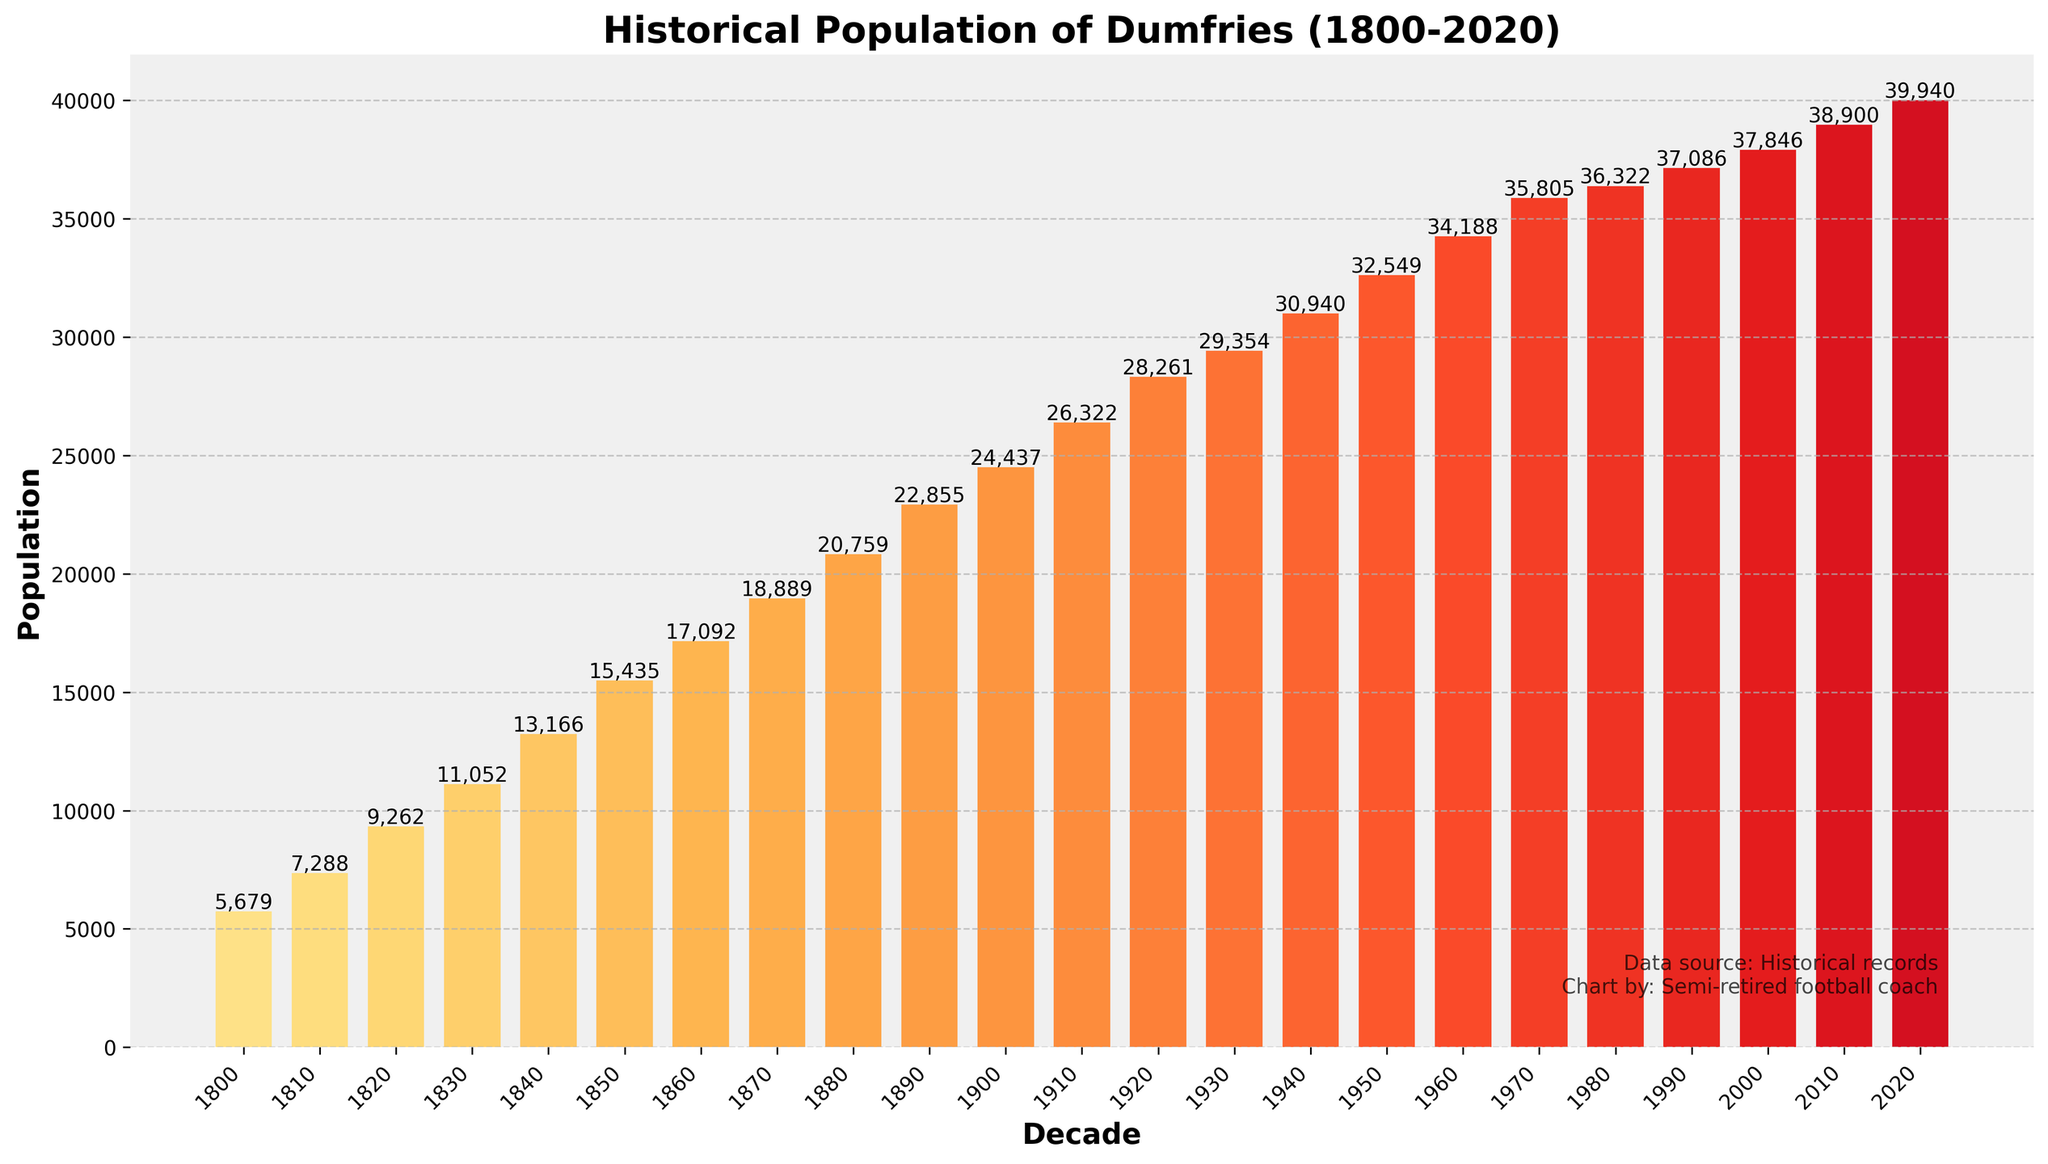what's the population change between 1800 and 2020? Subtract the population in 1800 (5,679) from the population in 2020 (39,940). The change is 39,940 - 5,679 = 34,261
Answer: 34,261 Which decade saw the largest increase in population? To find the largest increase, compare the population differences between consecutive decades. The largest difference occurs between 1820 (9,262) and 1830 (11,052), with an increase of 11,052 - 9,262 = 1,790
Answer: 1820-1830 Which decade has the smallest population? Looking at the bar heights, the 1800 decade has the smallest population, shown by the shortest bar with a population of 5,679
Answer: 1800 What is the average population from 2000 to 2020? Sum the populations of 2000 (37,846), 2010 (38,900), and 2020 (39,940) which is 37,846 + 38,900 + 39,940 = 116,686, then divide by 3. The average is 116,686 / 3 ≈ 38,895
Answer: 38,895 Was there any decade where the population growth was less than 1,000? Compare growth between each decade. Between 1980 (36,322) and 1990 (37,086), growth is 37,086 - 36,322 = 764, which is less than 1,000
Answer: 1980-1990 What colors are used for the bars representing the decades from 1960 to 2020? The bar colors range from yellow to dark red for decades from 1960 (yellowish) to 2020 (dark reddish).
Answer: yellow to dark red How many times does the population exceed 30,000? Identify bars taller than 30,000. They are 1940, 1950, 1960, 1970, 1980, 1990, 2000, 2010, 2020, so the count is 9 times
Answer: 9 What is the median population of all the decades? Listing the populations: [5,679, 7,288, 9,262, 11,052, 13,166, 15,435, 17,092, 18,889, 20,759, 22,855, 24,437, 26,322, 28,261, 29,354, 30,940, 32,549, 34,188, 35,805, 36,322, 37,086, 37,846, 38,900, 39,940]. The median is the middle value of this ordered list, which is 28,261 (1920)
Answer: 28,261 